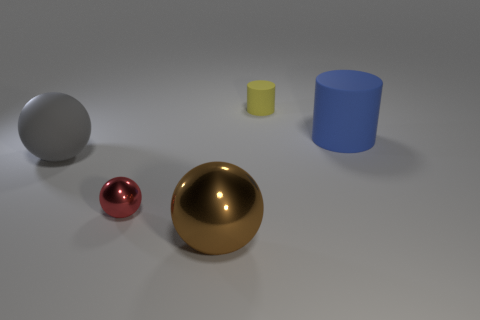Are there any large things that have the same color as the big matte sphere?
Offer a very short reply. No. Is there a big blue matte cylinder?
Make the answer very short. Yes. Does the large brown thing have the same shape as the tiny red thing?
Provide a short and direct response. Yes. How many big objects are gray matte spheres or blue things?
Provide a short and direct response. 2. What is the color of the large cylinder?
Your answer should be compact. Blue. What is the shape of the large rubber object that is to the left of the big rubber object that is right of the yellow matte object?
Provide a succinct answer. Sphere. Are there any small red objects that have the same material as the red sphere?
Give a very brief answer. No. Is the size of the metal sphere that is left of the brown thing the same as the brown shiny object?
Give a very brief answer. No. How many purple objects are matte objects or matte cylinders?
Give a very brief answer. 0. There is a small thing behind the gray sphere; what is it made of?
Ensure brevity in your answer.  Rubber. 